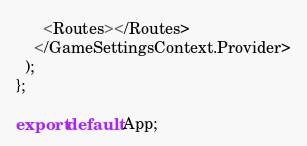Convert code to text. <code><loc_0><loc_0><loc_500><loc_500><_TypeScript_>      <Routes></Routes>
    </GameSettingsContext.Provider>
  );
};

export default App;
</code> 